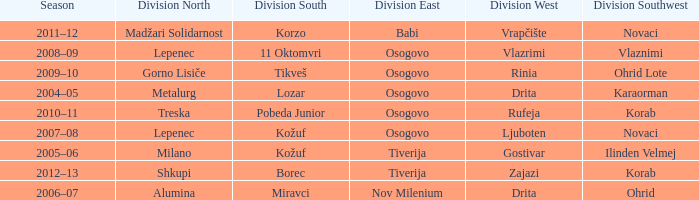Who won Division West when Division North was won by Alumina? Drita. 